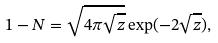<formula> <loc_0><loc_0><loc_500><loc_500>1 - N = \sqrt { 4 \pi \sqrt { z } } \exp ( - 2 \sqrt { z } ) ,</formula> 